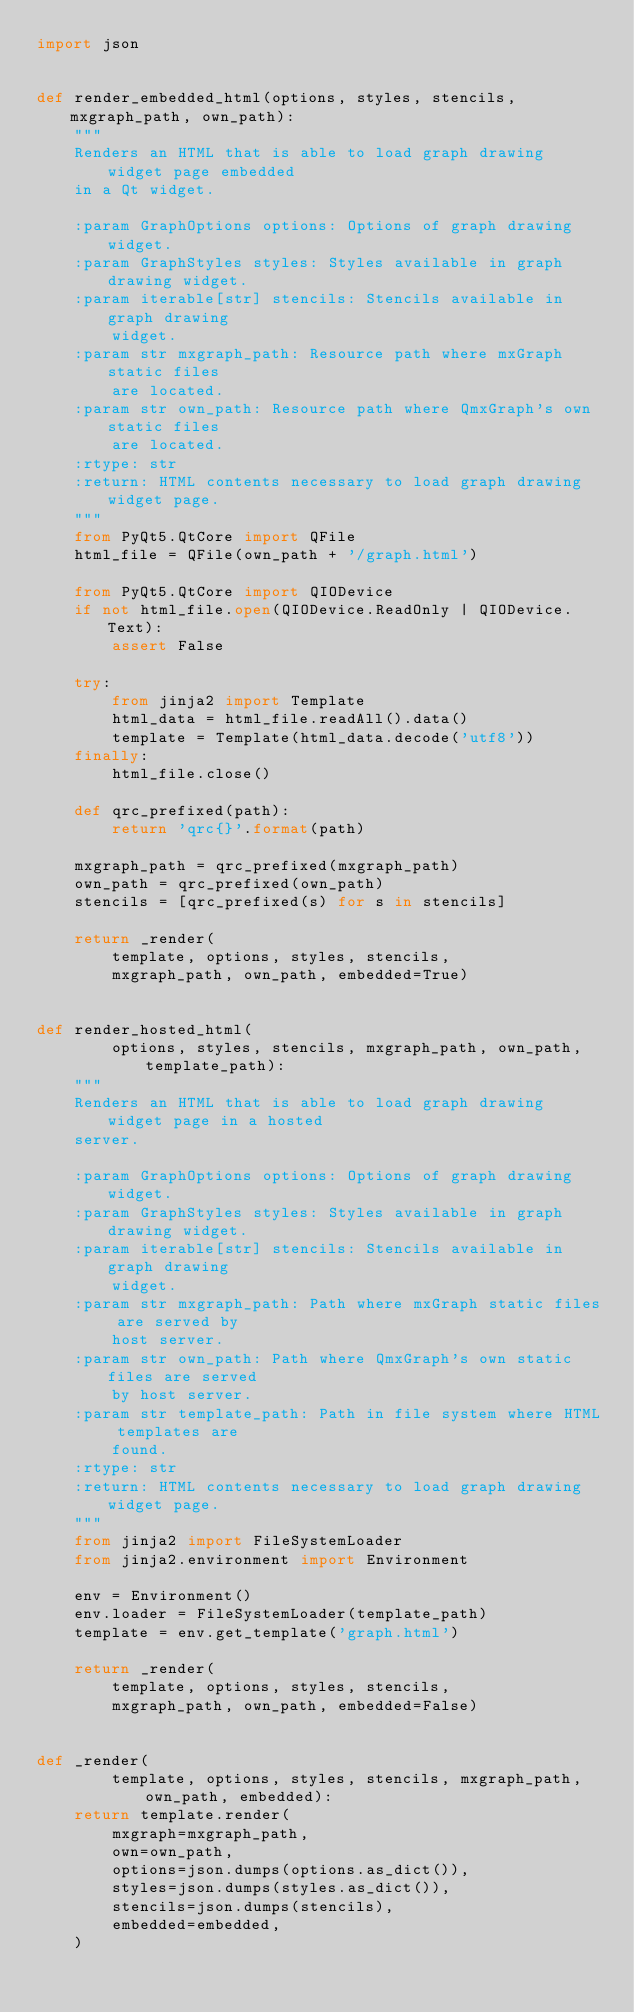<code> <loc_0><loc_0><loc_500><loc_500><_Python_>import json


def render_embedded_html(options, styles, stencils, mxgraph_path, own_path):
    """
    Renders an HTML that is able to load graph drawing widget page embedded
    in a Qt widget.

    :param GraphOptions options: Options of graph drawing widget.
    :param GraphStyles styles: Styles available in graph drawing widget.
    :param iterable[str] stencils: Stencils available in graph drawing
        widget.
    :param str mxgraph_path: Resource path where mxGraph static files
        are located.
    :param str own_path: Resource path where QmxGraph's own static files
        are located.
    :rtype: str
    :return: HTML contents necessary to load graph drawing widget page.
    """
    from PyQt5.QtCore import QFile
    html_file = QFile(own_path + '/graph.html')

    from PyQt5.QtCore import QIODevice
    if not html_file.open(QIODevice.ReadOnly | QIODevice.Text):
        assert False

    try:
        from jinja2 import Template
        html_data = html_file.readAll().data()
        template = Template(html_data.decode('utf8'))
    finally:
        html_file.close()

    def qrc_prefixed(path):
        return 'qrc{}'.format(path)

    mxgraph_path = qrc_prefixed(mxgraph_path)
    own_path = qrc_prefixed(own_path)
    stencils = [qrc_prefixed(s) for s in stencils]

    return _render(
        template, options, styles, stencils,
        mxgraph_path, own_path, embedded=True)


def render_hosted_html(
        options, styles, stencils, mxgraph_path, own_path, template_path):
    """
    Renders an HTML that is able to load graph drawing widget page in a hosted
    server.

    :param GraphOptions options: Options of graph drawing widget.
    :param GraphStyles styles: Styles available in graph drawing widget.
    :param iterable[str] stencils: Stencils available in graph drawing
        widget.
    :param str mxgraph_path: Path where mxGraph static files are served by
        host server.
    :param str own_path: Path where QmxGraph's own static files are served
        by host server.
    :param str template_path: Path in file system where HTML templates are
        found.
    :rtype: str
    :return: HTML contents necessary to load graph drawing widget page.
    """
    from jinja2 import FileSystemLoader
    from jinja2.environment import Environment

    env = Environment()
    env.loader = FileSystemLoader(template_path)
    template = env.get_template('graph.html')

    return _render(
        template, options, styles, stencils,
        mxgraph_path, own_path, embedded=False)


def _render(
        template, options, styles, stencils, mxgraph_path, own_path, embedded):
    return template.render(
        mxgraph=mxgraph_path,
        own=own_path,
        options=json.dumps(options.as_dict()),
        styles=json.dumps(styles.as_dict()),
        stencils=json.dumps(stencils),
        embedded=embedded,
    )
</code> 